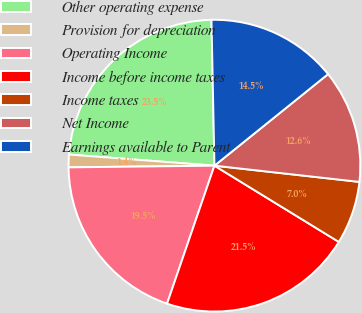<chart> <loc_0><loc_0><loc_500><loc_500><pie_chart><fcel>Other operating expense<fcel>Provision for depreciation<fcel>Operating Income<fcel>Income before income taxes<fcel>Income taxes<fcel>Net Income<fcel>Earnings available to Parent<nl><fcel>23.46%<fcel>1.4%<fcel>19.55%<fcel>21.51%<fcel>6.98%<fcel>12.57%<fcel>14.53%<nl></chart> 